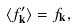<formula> <loc_0><loc_0><loc_500><loc_500>\langle f ^ { \prime } _ { \mathbf k } \rangle = f _ { \mathbf k } ,</formula> 